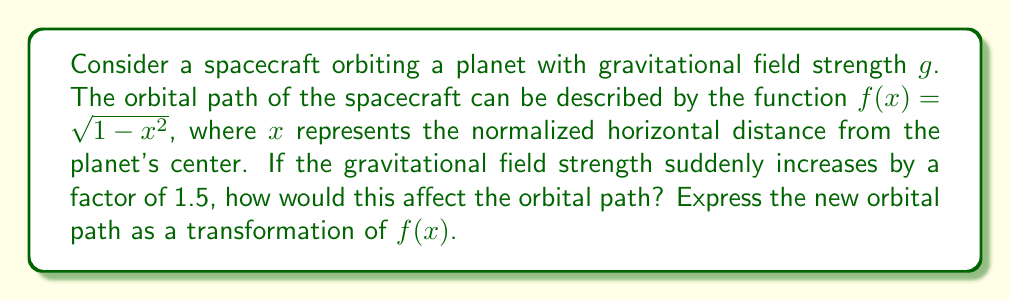Give your solution to this math problem. To solve this problem, we need to understand how changes in gravitational field strength affect orbital paths:

1) The orbital path is initially described by $f(x) = \sqrt{1-x^2}$, which represents a circular orbit.

2) An increase in gravitational field strength causes the spacecraft to be pulled closer to the planet, resulting in a vertical compression of the orbital path.

3) The factor of compression is inversely proportional to the square root of the increase in gravitational field strength. This is because the orbital radius is inversely proportional to the gravitational field strength, and the vertical component of the orbit scales with the radius.

4) The gravitational field strength increases by a factor of 1.5, so we calculate the compression factor:

   $$\text{Compression factor} = \frac{1}{\sqrt{1.5}} \approx 0.8165$$

5) To compress a function vertically by a factor $k$, we multiply the function by $k$:

   $$g(x) = 0.8165 \cdot f(x)$$

6) Substituting the original function:

   $$g(x) = 0.8165 \cdot \sqrt{1-x^2}$$

This represents the new orbital path as a transformation of the original function $f(x)$.
Answer: $g(x) = 0.8165 \cdot \sqrt{1-x^2}$ 